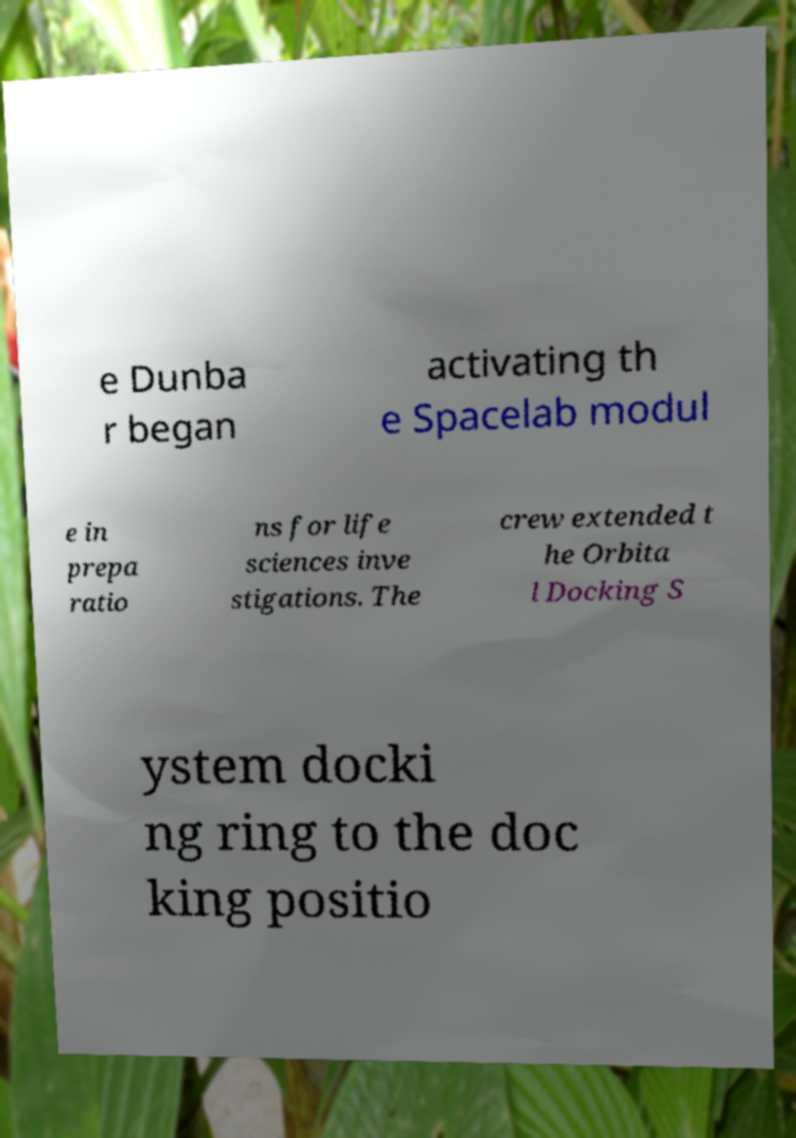Can you accurately transcribe the text from the provided image for me? e Dunba r began activating th e Spacelab modul e in prepa ratio ns for life sciences inve stigations. The crew extended t he Orbita l Docking S ystem docki ng ring to the doc king positio 